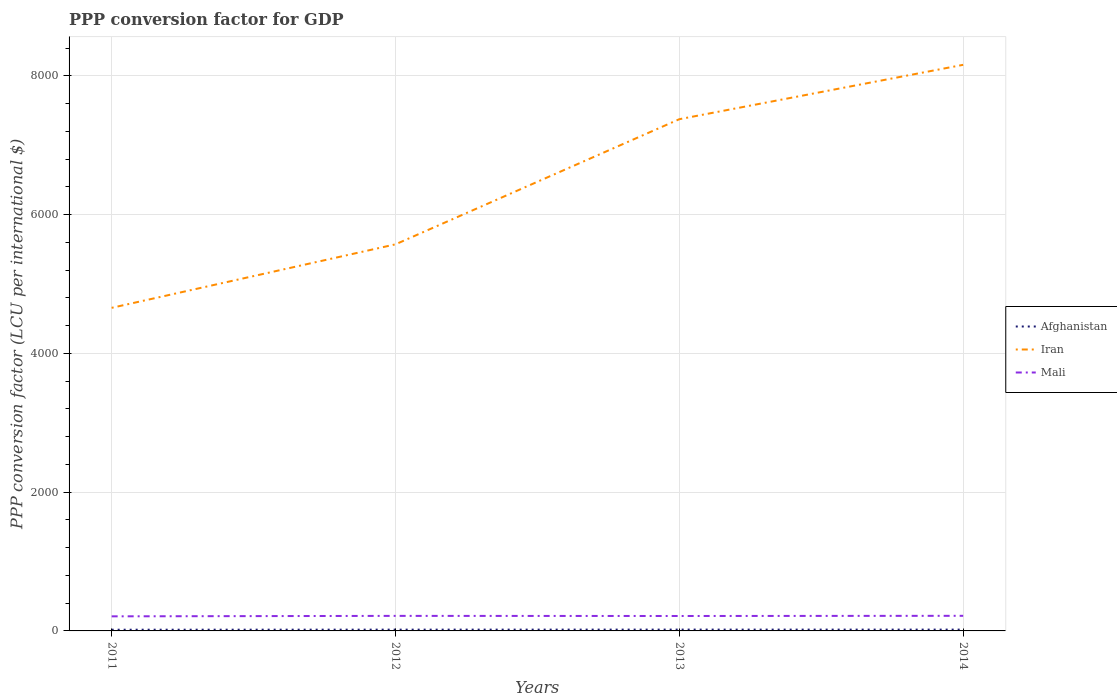How many different coloured lines are there?
Offer a terse response. 3. Does the line corresponding to Iran intersect with the line corresponding to Mali?
Your answer should be very brief. No. Across all years, what is the maximum PPP conversion factor for GDP in Afghanistan?
Give a very brief answer. 17.36. What is the total PPP conversion factor for GDP in Afghanistan in the graph?
Offer a very short reply. 0.23. What is the difference between the highest and the second highest PPP conversion factor for GDP in Afghanistan?
Your answer should be compact. 1.7. How many years are there in the graph?
Offer a very short reply. 4. Does the graph contain grids?
Keep it short and to the point. Yes. Where does the legend appear in the graph?
Your answer should be compact. Center right. What is the title of the graph?
Your response must be concise. PPP conversion factor for GDP. What is the label or title of the X-axis?
Provide a short and direct response. Years. What is the label or title of the Y-axis?
Give a very brief answer. PPP conversion factor (LCU per international $). What is the PPP conversion factor (LCU per international $) in Afghanistan in 2011?
Make the answer very short. 17.36. What is the PPP conversion factor (LCU per international $) of Iran in 2011?
Keep it short and to the point. 4657.46. What is the PPP conversion factor (LCU per international $) of Mali in 2011?
Your response must be concise. 210.19. What is the PPP conversion factor (LCU per international $) in Afghanistan in 2012?
Provide a short and direct response. 18.47. What is the PPP conversion factor (LCU per international $) in Iran in 2012?
Give a very brief answer. 5572.81. What is the PPP conversion factor (LCU per international $) of Mali in 2012?
Make the answer very short. 216.9. What is the PPP conversion factor (LCU per international $) in Afghanistan in 2013?
Offer a terse response. 19.05. What is the PPP conversion factor (LCU per international $) of Iran in 2013?
Ensure brevity in your answer.  7376.64. What is the PPP conversion factor (LCU per international $) in Mali in 2013?
Keep it short and to the point. 215.18. What is the PPP conversion factor (LCU per international $) of Afghanistan in 2014?
Provide a succinct answer. 18.82. What is the PPP conversion factor (LCU per international $) in Iran in 2014?
Offer a very short reply. 8160.48. What is the PPP conversion factor (LCU per international $) in Mali in 2014?
Ensure brevity in your answer.  217.81. Across all years, what is the maximum PPP conversion factor (LCU per international $) of Afghanistan?
Your response must be concise. 19.05. Across all years, what is the maximum PPP conversion factor (LCU per international $) in Iran?
Your answer should be compact. 8160.48. Across all years, what is the maximum PPP conversion factor (LCU per international $) of Mali?
Ensure brevity in your answer.  217.81. Across all years, what is the minimum PPP conversion factor (LCU per international $) of Afghanistan?
Offer a terse response. 17.36. Across all years, what is the minimum PPP conversion factor (LCU per international $) in Iran?
Your answer should be very brief. 4657.46. Across all years, what is the minimum PPP conversion factor (LCU per international $) in Mali?
Provide a succinct answer. 210.19. What is the total PPP conversion factor (LCU per international $) in Afghanistan in the graph?
Ensure brevity in your answer.  73.7. What is the total PPP conversion factor (LCU per international $) in Iran in the graph?
Offer a very short reply. 2.58e+04. What is the total PPP conversion factor (LCU per international $) of Mali in the graph?
Ensure brevity in your answer.  860.09. What is the difference between the PPP conversion factor (LCU per international $) in Afghanistan in 2011 and that in 2012?
Give a very brief answer. -1.11. What is the difference between the PPP conversion factor (LCU per international $) of Iran in 2011 and that in 2012?
Make the answer very short. -915.35. What is the difference between the PPP conversion factor (LCU per international $) of Mali in 2011 and that in 2012?
Make the answer very short. -6.71. What is the difference between the PPP conversion factor (LCU per international $) in Afghanistan in 2011 and that in 2013?
Provide a short and direct response. -1.7. What is the difference between the PPP conversion factor (LCU per international $) of Iran in 2011 and that in 2013?
Keep it short and to the point. -2719.17. What is the difference between the PPP conversion factor (LCU per international $) of Mali in 2011 and that in 2013?
Provide a short and direct response. -4.99. What is the difference between the PPP conversion factor (LCU per international $) of Afghanistan in 2011 and that in 2014?
Offer a very short reply. -1.47. What is the difference between the PPP conversion factor (LCU per international $) in Iran in 2011 and that in 2014?
Your answer should be compact. -3503.02. What is the difference between the PPP conversion factor (LCU per international $) of Mali in 2011 and that in 2014?
Offer a terse response. -7.61. What is the difference between the PPP conversion factor (LCU per international $) in Afghanistan in 2012 and that in 2013?
Your answer should be compact. -0.59. What is the difference between the PPP conversion factor (LCU per international $) in Iran in 2012 and that in 2013?
Offer a terse response. -1803.83. What is the difference between the PPP conversion factor (LCU per international $) of Mali in 2012 and that in 2013?
Provide a succinct answer. 1.72. What is the difference between the PPP conversion factor (LCU per international $) in Afghanistan in 2012 and that in 2014?
Your answer should be very brief. -0.36. What is the difference between the PPP conversion factor (LCU per international $) of Iran in 2012 and that in 2014?
Your answer should be compact. -2587.67. What is the difference between the PPP conversion factor (LCU per international $) in Mali in 2012 and that in 2014?
Your answer should be very brief. -0.9. What is the difference between the PPP conversion factor (LCU per international $) of Afghanistan in 2013 and that in 2014?
Give a very brief answer. 0.23. What is the difference between the PPP conversion factor (LCU per international $) in Iran in 2013 and that in 2014?
Ensure brevity in your answer.  -783.85. What is the difference between the PPP conversion factor (LCU per international $) of Mali in 2013 and that in 2014?
Make the answer very short. -2.62. What is the difference between the PPP conversion factor (LCU per international $) of Afghanistan in 2011 and the PPP conversion factor (LCU per international $) of Iran in 2012?
Provide a succinct answer. -5555.45. What is the difference between the PPP conversion factor (LCU per international $) of Afghanistan in 2011 and the PPP conversion factor (LCU per international $) of Mali in 2012?
Ensure brevity in your answer.  -199.55. What is the difference between the PPP conversion factor (LCU per international $) in Iran in 2011 and the PPP conversion factor (LCU per international $) in Mali in 2012?
Your answer should be very brief. 4440.56. What is the difference between the PPP conversion factor (LCU per international $) in Afghanistan in 2011 and the PPP conversion factor (LCU per international $) in Iran in 2013?
Ensure brevity in your answer.  -7359.28. What is the difference between the PPP conversion factor (LCU per international $) of Afghanistan in 2011 and the PPP conversion factor (LCU per international $) of Mali in 2013?
Give a very brief answer. -197.83. What is the difference between the PPP conversion factor (LCU per international $) of Iran in 2011 and the PPP conversion factor (LCU per international $) of Mali in 2013?
Your answer should be very brief. 4442.28. What is the difference between the PPP conversion factor (LCU per international $) of Afghanistan in 2011 and the PPP conversion factor (LCU per international $) of Iran in 2014?
Offer a very short reply. -8143.13. What is the difference between the PPP conversion factor (LCU per international $) in Afghanistan in 2011 and the PPP conversion factor (LCU per international $) in Mali in 2014?
Offer a very short reply. -200.45. What is the difference between the PPP conversion factor (LCU per international $) in Iran in 2011 and the PPP conversion factor (LCU per international $) in Mali in 2014?
Your response must be concise. 4439.66. What is the difference between the PPP conversion factor (LCU per international $) in Afghanistan in 2012 and the PPP conversion factor (LCU per international $) in Iran in 2013?
Offer a terse response. -7358.17. What is the difference between the PPP conversion factor (LCU per international $) in Afghanistan in 2012 and the PPP conversion factor (LCU per international $) in Mali in 2013?
Your response must be concise. -196.72. What is the difference between the PPP conversion factor (LCU per international $) in Iran in 2012 and the PPP conversion factor (LCU per international $) in Mali in 2013?
Provide a succinct answer. 5357.63. What is the difference between the PPP conversion factor (LCU per international $) of Afghanistan in 2012 and the PPP conversion factor (LCU per international $) of Iran in 2014?
Ensure brevity in your answer.  -8142.02. What is the difference between the PPP conversion factor (LCU per international $) of Afghanistan in 2012 and the PPP conversion factor (LCU per international $) of Mali in 2014?
Provide a short and direct response. -199.34. What is the difference between the PPP conversion factor (LCU per international $) in Iran in 2012 and the PPP conversion factor (LCU per international $) in Mali in 2014?
Offer a very short reply. 5355. What is the difference between the PPP conversion factor (LCU per international $) of Afghanistan in 2013 and the PPP conversion factor (LCU per international $) of Iran in 2014?
Offer a very short reply. -8141.43. What is the difference between the PPP conversion factor (LCU per international $) of Afghanistan in 2013 and the PPP conversion factor (LCU per international $) of Mali in 2014?
Keep it short and to the point. -198.75. What is the difference between the PPP conversion factor (LCU per international $) of Iran in 2013 and the PPP conversion factor (LCU per international $) of Mali in 2014?
Keep it short and to the point. 7158.83. What is the average PPP conversion factor (LCU per international $) in Afghanistan per year?
Your response must be concise. 18.43. What is the average PPP conversion factor (LCU per international $) of Iran per year?
Ensure brevity in your answer.  6441.85. What is the average PPP conversion factor (LCU per international $) of Mali per year?
Your response must be concise. 215.02. In the year 2011, what is the difference between the PPP conversion factor (LCU per international $) of Afghanistan and PPP conversion factor (LCU per international $) of Iran?
Make the answer very short. -4640.11. In the year 2011, what is the difference between the PPP conversion factor (LCU per international $) in Afghanistan and PPP conversion factor (LCU per international $) in Mali?
Offer a very short reply. -192.84. In the year 2011, what is the difference between the PPP conversion factor (LCU per international $) in Iran and PPP conversion factor (LCU per international $) in Mali?
Keep it short and to the point. 4447.27. In the year 2012, what is the difference between the PPP conversion factor (LCU per international $) in Afghanistan and PPP conversion factor (LCU per international $) in Iran?
Provide a succinct answer. -5554.34. In the year 2012, what is the difference between the PPP conversion factor (LCU per international $) of Afghanistan and PPP conversion factor (LCU per international $) of Mali?
Give a very brief answer. -198.44. In the year 2012, what is the difference between the PPP conversion factor (LCU per international $) of Iran and PPP conversion factor (LCU per international $) of Mali?
Your response must be concise. 5355.91. In the year 2013, what is the difference between the PPP conversion factor (LCU per international $) of Afghanistan and PPP conversion factor (LCU per international $) of Iran?
Your answer should be compact. -7357.58. In the year 2013, what is the difference between the PPP conversion factor (LCU per international $) in Afghanistan and PPP conversion factor (LCU per international $) in Mali?
Your answer should be compact. -196.13. In the year 2013, what is the difference between the PPP conversion factor (LCU per international $) in Iran and PPP conversion factor (LCU per international $) in Mali?
Offer a very short reply. 7161.45. In the year 2014, what is the difference between the PPP conversion factor (LCU per international $) in Afghanistan and PPP conversion factor (LCU per international $) in Iran?
Your answer should be compact. -8141.66. In the year 2014, what is the difference between the PPP conversion factor (LCU per international $) in Afghanistan and PPP conversion factor (LCU per international $) in Mali?
Keep it short and to the point. -198.98. In the year 2014, what is the difference between the PPP conversion factor (LCU per international $) in Iran and PPP conversion factor (LCU per international $) in Mali?
Make the answer very short. 7942.68. What is the ratio of the PPP conversion factor (LCU per international $) of Afghanistan in 2011 to that in 2012?
Keep it short and to the point. 0.94. What is the ratio of the PPP conversion factor (LCU per international $) in Iran in 2011 to that in 2012?
Give a very brief answer. 0.84. What is the ratio of the PPP conversion factor (LCU per international $) of Mali in 2011 to that in 2012?
Your answer should be very brief. 0.97. What is the ratio of the PPP conversion factor (LCU per international $) of Afghanistan in 2011 to that in 2013?
Keep it short and to the point. 0.91. What is the ratio of the PPP conversion factor (LCU per international $) in Iran in 2011 to that in 2013?
Your response must be concise. 0.63. What is the ratio of the PPP conversion factor (LCU per international $) of Mali in 2011 to that in 2013?
Offer a terse response. 0.98. What is the ratio of the PPP conversion factor (LCU per international $) of Afghanistan in 2011 to that in 2014?
Your answer should be very brief. 0.92. What is the ratio of the PPP conversion factor (LCU per international $) in Iran in 2011 to that in 2014?
Your answer should be compact. 0.57. What is the ratio of the PPP conversion factor (LCU per international $) of Afghanistan in 2012 to that in 2013?
Offer a terse response. 0.97. What is the ratio of the PPP conversion factor (LCU per international $) of Iran in 2012 to that in 2013?
Your response must be concise. 0.76. What is the ratio of the PPP conversion factor (LCU per international $) in Mali in 2012 to that in 2013?
Your answer should be compact. 1.01. What is the ratio of the PPP conversion factor (LCU per international $) of Afghanistan in 2012 to that in 2014?
Provide a succinct answer. 0.98. What is the ratio of the PPP conversion factor (LCU per international $) of Iran in 2012 to that in 2014?
Offer a terse response. 0.68. What is the ratio of the PPP conversion factor (LCU per international $) of Afghanistan in 2013 to that in 2014?
Give a very brief answer. 1.01. What is the ratio of the PPP conversion factor (LCU per international $) of Iran in 2013 to that in 2014?
Provide a short and direct response. 0.9. What is the difference between the highest and the second highest PPP conversion factor (LCU per international $) in Afghanistan?
Keep it short and to the point. 0.23. What is the difference between the highest and the second highest PPP conversion factor (LCU per international $) of Iran?
Offer a terse response. 783.85. What is the difference between the highest and the second highest PPP conversion factor (LCU per international $) in Mali?
Ensure brevity in your answer.  0.9. What is the difference between the highest and the lowest PPP conversion factor (LCU per international $) in Afghanistan?
Make the answer very short. 1.7. What is the difference between the highest and the lowest PPP conversion factor (LCU per international $) in Iran?
Your response must be concise. 3503.02. What is the difference between the highest and the lowest PPP conversion factor (LCU per international $) of Mali?
Offer a terse response. 7.61. 